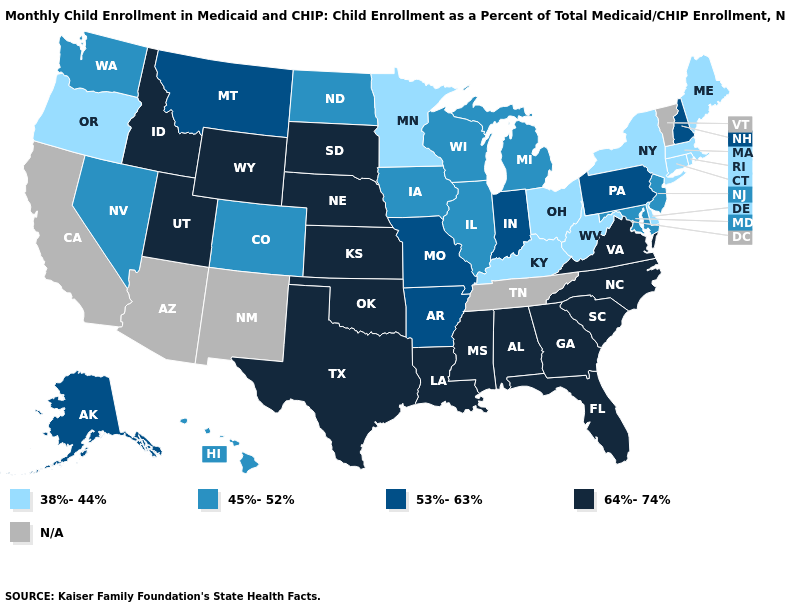Name the states that have a value in the range N/A?
Concise answer only. Arizona, California, New Mexico, Tennessee, Vermont. What is the value of California?
Answer briefly. N/A. What is the value of Alabama?
Keep it brief. 64%-74%. What is the value of South Dakota?
Answer briefly. 64%-74%. Name the states that have a value in the range 64%-74%?
Concise answer only. Alabama, Florida, Georgia, Idaho, Kansas, Louisiana, Mississippi, Nebraska, North Carolina, Oklahoma, South Carolina, South Dakota, Texas, Utah, Virginia, Wyoming. Among the states that border Washington , does Idaho have the highest value?
Quick response, please. Yes. Name the states that have a value in the range 38%-44%?
Write a very short answer. Connecticut, Delaware, Kentucky, Maine, Massachusetts, Minnesota, New York, Ohio, Oregon, Rhode Island, West Virginia. What is the value of West Virginia?
Quick response, please. 38%-44%. What is the value of West Virginia?
Give a very brief answer. 38%-44%. Among the states that border Arizona , which have the lowest value?
Keep it brief. Colorado, Nevada. What is the lowest value in the USA?
Write a very short answer. 38%-44%. Name the states that have a value in the range 38%-44%?
Quick response, please. Connecticut, Delaware, Kentucky, Maine, Massachusetts, Minnesota, New York, Ohio, Oregon, Rhode Island, West Virginia. What is the value of New Jersey?
Write a very short answer. 45%-52%. Name the states that have a value in the range 64%-74%?
Write a very short answer. Alabama, Florida, Georgia, Idaho, Kansas, Louisiana, Mississippi, Nebraska, North Carolina, Oklahoma, South Carolina, South Dakota, Texas, Utah, Virginia, Wyoming. 